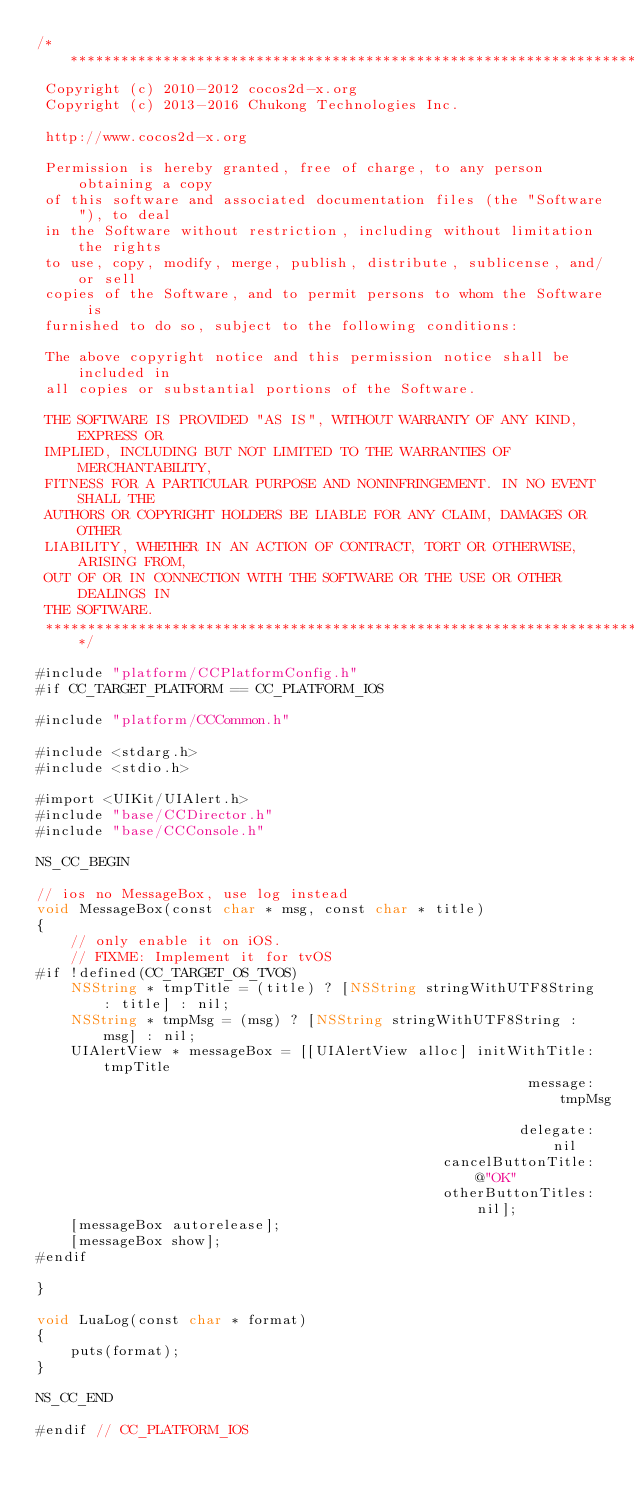Convert code to text. <code><loc_0><loc_0><loc_500><loc_500><_ObjectiveC_>/****************************************************************************
 Copyright (c) 2010-2012 cocos2d-x.org
 Copyright (c) 2013-2016 Chukong Technologies Inc.

 http://www.cocos2d-x.org

 Permission is hereby granted, free of charge, to any person obtaining a copy
 of this software and associated documentation files (the "Software"), to deal
 in the Software without restriction, including without limitation the rights
 to use, copy, modify, merge, publish, distribute, sublicense, and/or sell
 copies of the Software, and to permit persons to whom the Software is
 furnished to do so, subject to the following conditions:

 The above copyright notice and this permission notice shall be included in
 all copies or substantial portions of the Software.

 THE SOFTWARE IS PROVIDED "AS IS", WITHOUT WARRANTY OF ANY KIND, EXPRESS OR
 IMPLIED, INCLUDING BUT NOT LIMITED TO THE WARRANTIES OF MERCHANTABILITY,
 FITNESS FOR A PARTICULAR PURPOSE AND NONINFRINGEMENT. IN NO EVENT SHALL THE
 AUTHORS OR COPYRIGHT HOLDERS BE LIABLE FOR ANY CLAIM, DAMAGES OR OTHER
 LIABILITY, WHETHER IN AN ACTION OF CONTRACT, TORT OR OTHERWISE, ARISING FROM,
 OUT OF OR IN CONNECTION WITH THE SOFTWARE OR THE USE OR OTHER DEALINGS IN
 THE SOFTWARE.
 ****************************************************************************/

#include "platform/CCPlatformConfig.h"
#if CC_TARGET_PLATFORM == CC_PLATFORM_IOS

#include "platform/CCCommon.h"

#include <stdarg.h>
#include <stdio.h>

#import <UIKit/UIAlert.h>
#include "base/CCDirector.h"
#include "base/CCConsole.h"

NS_CC_BEGIN

// ios no MessageBox, use log instead
void MessageBox(const char * msg, const char * title)
{
    // only enable it on iOS.
    // FIXME: Implement it for tvOS
#if !defined(CC_TARGET_OS_TVOS)
    NSString * tmpTitle = (title) ? [NSString stringWithUTF8String : title] : nil;
    NSString * tmpMsg = (msg) ? [NSString stringWithUTF8String : msg] : nil;
    UIAlertView * messageBox = [[UIAlertView alloc] initWithTitle: tmpTitle
                                                          message: tmpMsg
                                                         delegate: nil
                                                cancelButtonTitle: @"OK"
                                                otherButtonTitles: nil];
    [messageBox autorelease];
    [messageBox show];
#endif

}

void LuaLog(const char * format)
{
    puts(format);
}

NS_CC_END

#endif // CC_PLATFORM_IOS
</code> 